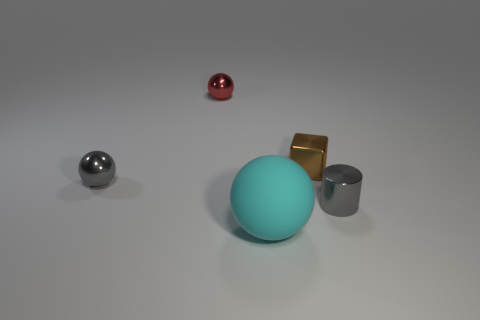How is the lighting affecting the appearance of the objects? The lighting in the image is soft and diffused, creating gentle shadows and subtle highlights on the objects. This soft lighting enhances the reflective quality of the metallic surfaces and accentuates the matte finish of the cyan sphere. 